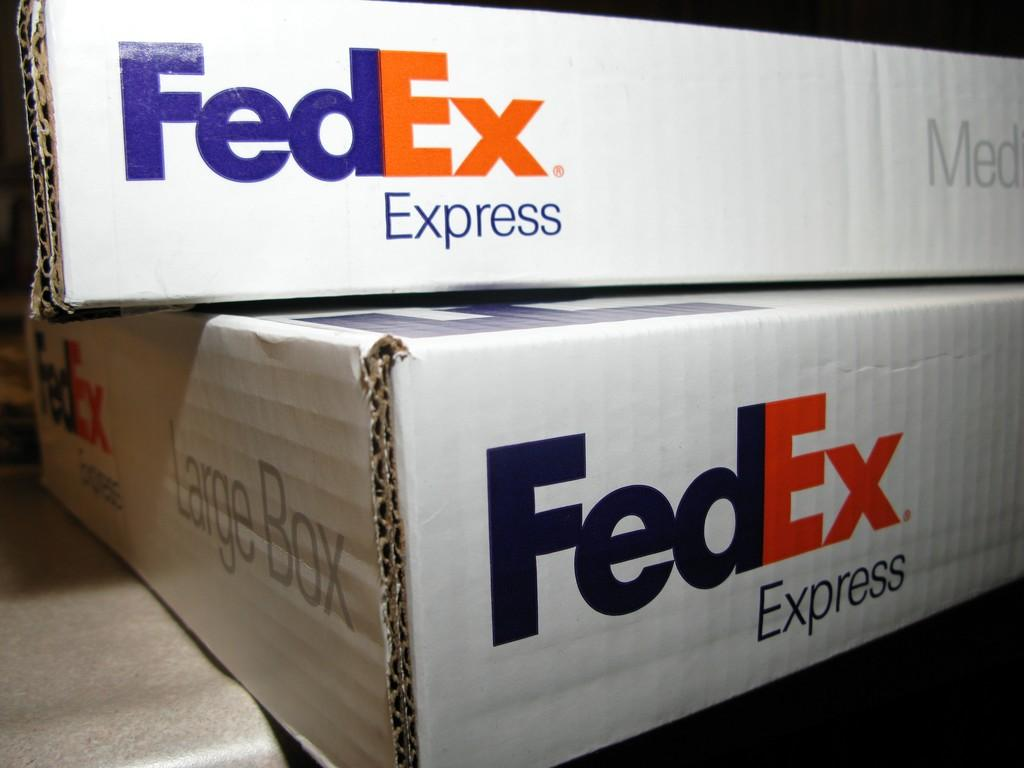<image>
Share a concise interpretation of the image provided. A medium FedEx Express box can stack on top of a large FedEx Express box. 